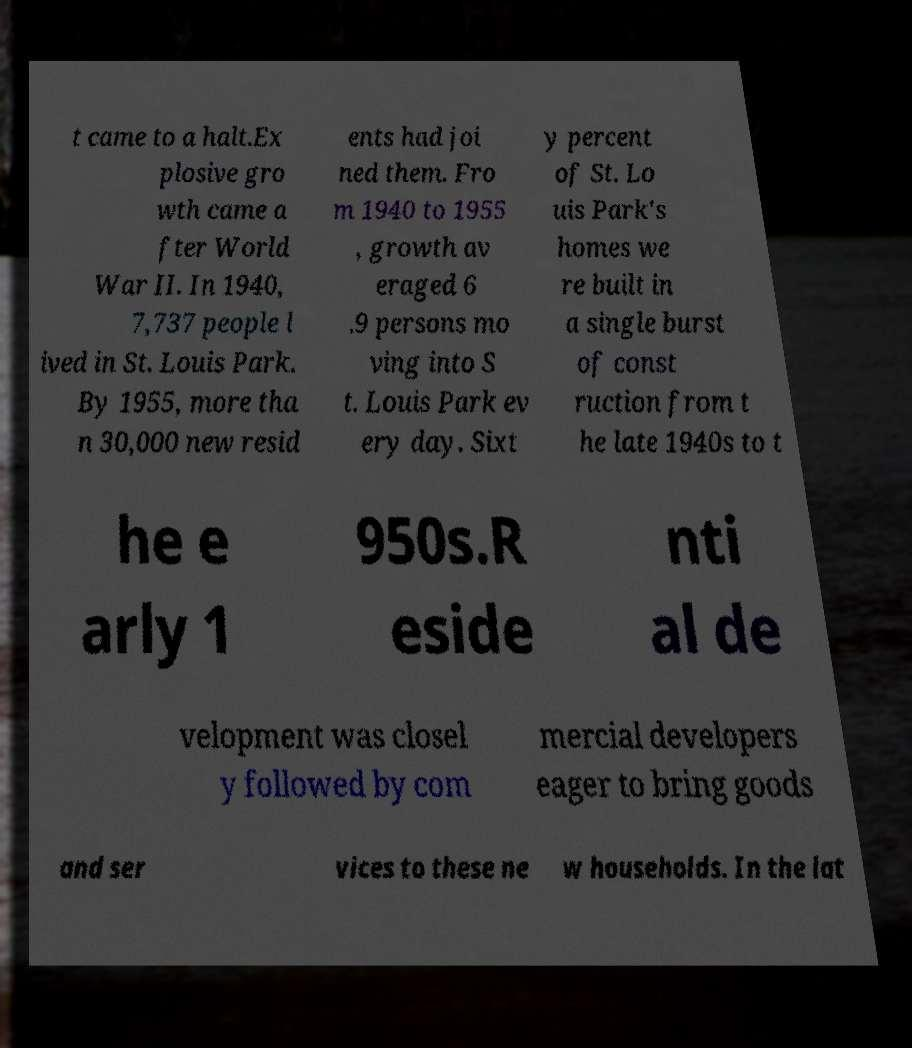For documentation purposes, I need the text within this image transcribed. Could you provide that? t came to a halt.Ex plosive gro wth came a fter World War II. In 1940, 7,737 people l ived in St. Louis Park. By 1955, more tha n 30,000 new resid ents had joi ned them. Fro m 1940 to 1955 , growth av eraged 6 .9 persons mo ving into S t. Louis Park ev ery day. Sixt y percent of St. Lo uis Park's homes we re built in a single burst of const ruction from t he late 1940s to t he e arly 1 950s.R eside nti al de velopment was closel y followed by com mercial developers eager to bring goods and ser vices to these ne w households. In the lat 